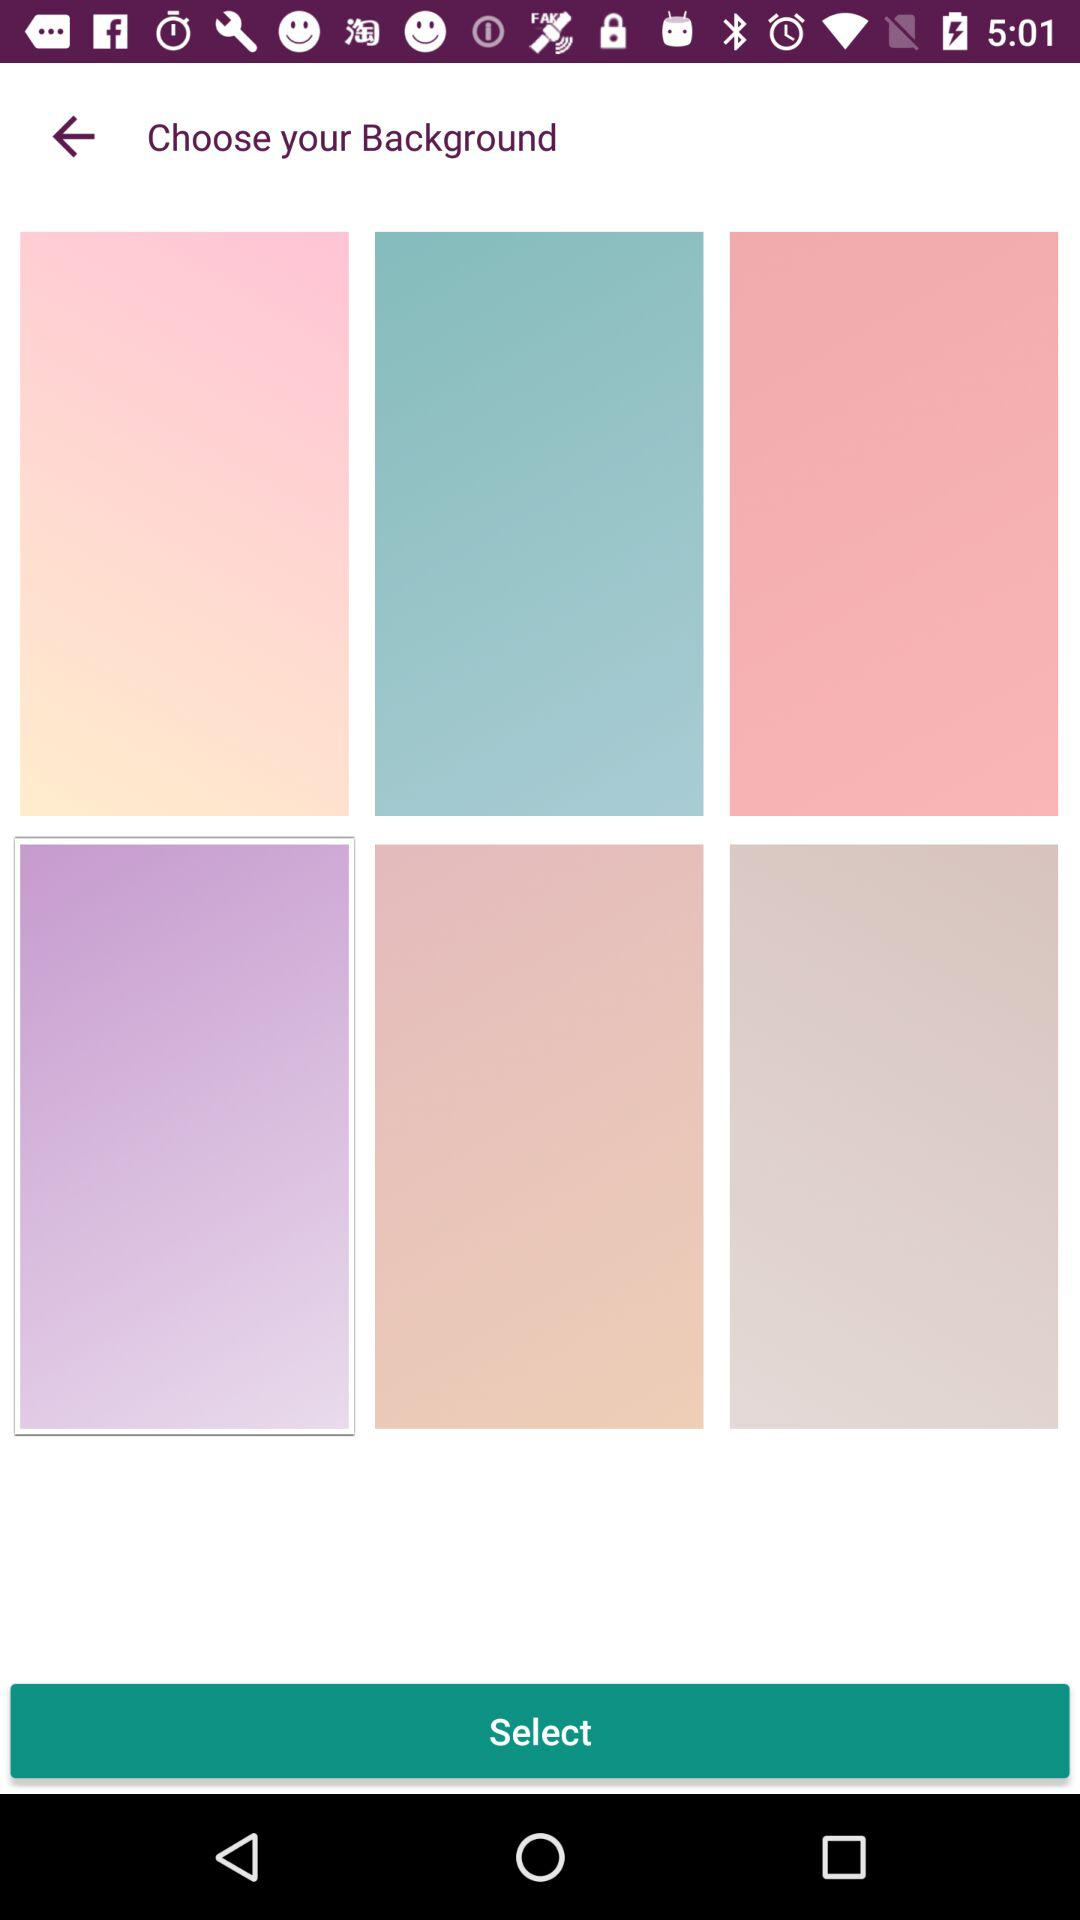How many pink backgrounds are there?
Answer the question using a single word or phrase. 3 